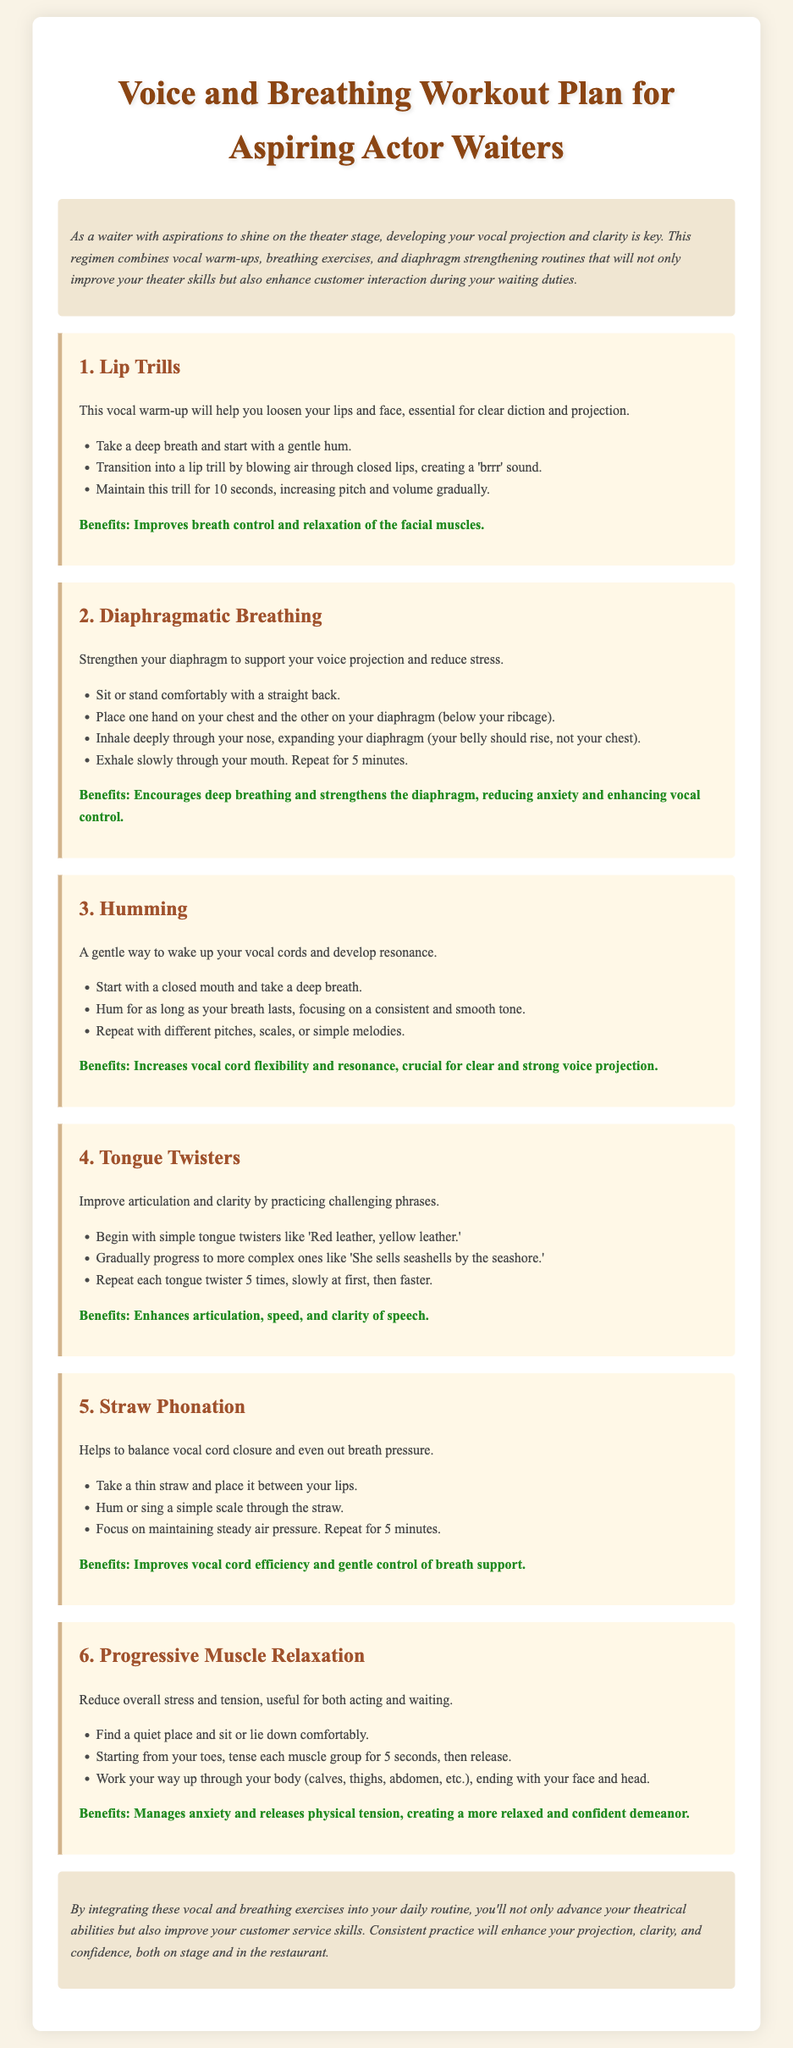What is the title of the workout plan? The title is stated at the beginning of the document and is "Voice and Breathing Workout Plan for Aspiring Actor Waiters."
Answer: Voice and Breathing Workout Plan for Aspiring Actor Waiters How many exercises are included in the workout plan? The document lists a total of six exercises designed to improve vocal projection and clarity.
Answer: 6 What is the benefit of Lip Trills? The benefits of Lip Trills are mentioned in the exercise description, which states they improve breath control and relaxation of the facial muscles.
Answer: Improves breath control and relaxation of the facial muscles What should you focus on during Diaphragmatic Breathing? The exercise notes that you should focus on expanding your diaphragm (your belly should rise, not your chest) while breathing.
Answer: Expanding your diaphragm Which exercise helps reduce overall stress? The document specifically mentions Progressive Muscle Relaxation as an exercise designed to manage anxiety and release physical tension.
Answer: Progressive Muscle Relaxation What is one of the main goals of these exercises? The introduction states that a key focus of the regimen is to improve vocal projection and clarity.
Answer: Improve vocal projection and clarity How long should you perform Straw Phonation? The exercise instructions indicate that you should repeat Straw Phonation for a duration of 5 minutes.
Answer: 5 minutes What is the focus of Humming as an exercise? The description indicates that the focus of Humming is on maintaining a consistent and smooth tone.
Answer: Consistent and smooth tone 